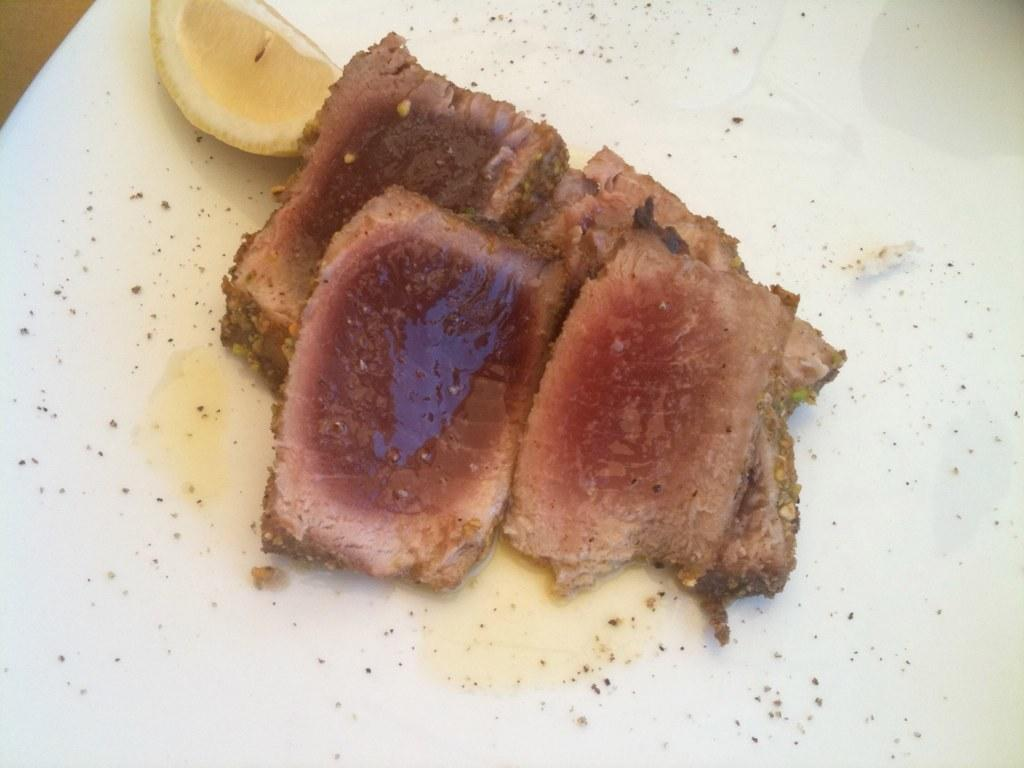What color is the plate in the image? The plate in the image is white colored. What type of food item is on the plate? There is a brown food item on the plate. What additional item is on the plate? There is a piece of lemon on the plate. What type of game is being played on the plate in the image? There is no game being played on the plate in the image; it contains a brown food item and a piece of lemon. 